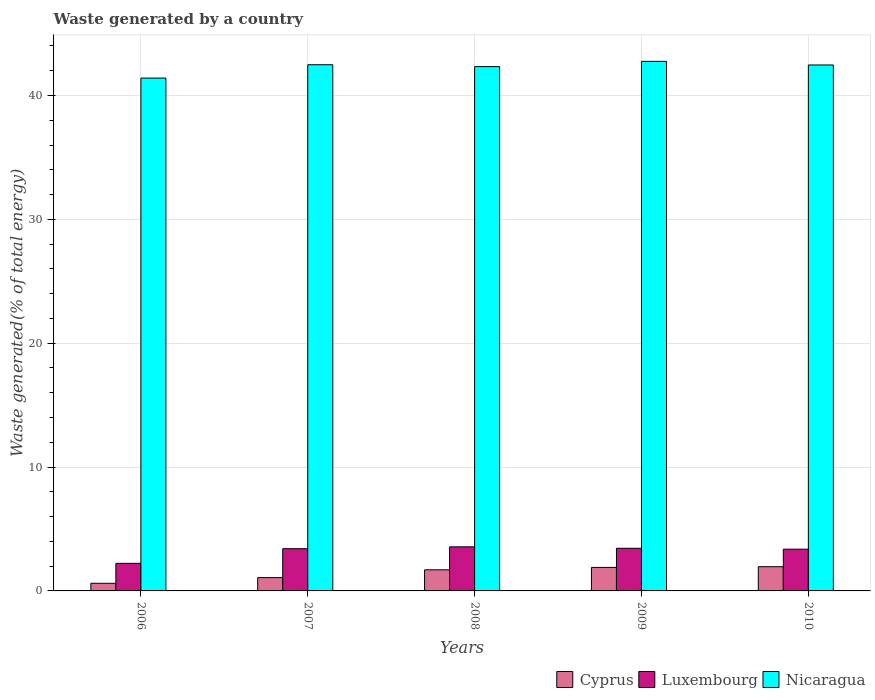How many different coloured bars are there?
Provide a succinct answer. 3. Are the number of bars per tick equal to the number of legend labels?
Provide a succinct answer. Yes. Are the number of bars on each tick of the X-axis equal?
Offer a very short reply. Yes. How many bars are there on the 4th tick from the left?
Keep it short and to the point. 3. How many bars are there on the 5th tick from the right?
Give a very brief answer. 3. What is the total waste generated in Cyprus in 2008?
Offer a very short reply. 1.7. Across all years, what is the maximum total waste generated in Luxembourg?
Make the answer very short. 3.56. Across all years, what is the minimum total waste generated in Luxembourg?
Your answer should be very brief. 2.23. In which year was the total waste generated in Cyprus maximum?
Ensure brevity in your answer.  2010. What is the total total waste generated in Luxembourg in the graph?
Offer a very short reply. 16.01. What is the difference between the total waste generated in Nicaragua in 2009 and that in 2010?
Your response must be concise. 0.29. What is the difference between the total waste generated in Nicaragua in 2007 and the total waste generated in Cyprus in 2010?
Your answer should be compact. 40.53. What is the average total waste generated in Luxembourg per year?
Your response must be concise. 3.2. In the year 2009, what is the difference between the total waste generated in Cyprus and total waste generated in Luxembourg?
Your response must be concise. -1.55. In how many years, is the total waste generated in Cyprus greater than 16 %?
Your answer should be compact. 0. What is the ratio of the total waste generated in Luxembourg in 2009 to that in 2010?
Provide a succinct answer. 1.02. What is the difference between the highest and the second highest total waste generated in Nicaragua?
Provide a short and direct response. 0.27. What is the difference between the highest and the lowest total waste generated in Luxembourg?
Give a very brief answer. 1.33. In how many years, is the total waste generated in Luxembourg greater than the average total waste generated in Luxembourg taken over all years?
Provide a succinct answer. 4. What does the 1st bar from the left in 2008 represents?
Give a very brief answer. Cyprus. What does the 2nd bar from the right in 2008 represents?
Your answer should be compact. Luxembourg. How many bars are there?
Give a very brief answer. 15. Are all the bars in the graph horizontal?
Make the answer very short. No. How many years are there in the graph?
Offer a very short reply. 5. Are the values on the major ticks of Y-axis written in scientific E-notation?
Ensure brevity in your answer.  No. How are the legend labels stacked?
Your response must be concise. Horizontal. What is the title of the graph?
Your answer should be compact. Waste generated by a country. Does "Belarus" appear as one of the legend labels in the graph?
Offer a very short reply. No. What is the label or title of the Y-axis?
Offer a terse response. Waste generated(% of total energy). What is the Waste generated(% of total energy) in Cyprus in 2006?
Provide a succinct answer. 0.62. What is the Waste generated(% of total energy) in Luxembourg in 2006?
Offer a very short reply. 2.23. What is the Waste generated(% of total energy) of Nicaragua in 2006?
Your response must be concise. 41.41. What is the Waste generated(% of total energy) of Cyprus in 2007?
Your answer should be compact. 1.07. What is the Waste generated(% of total energy) of Luxembourg in 2007?
Give a very brief answer. 3.41. What is the Waste generated(% of total energy) in Nicaragua in 2007?
Keep it short and to the point. 42.48. What is the Waste generated(% of total energy) in Cyprus in 2008?
Offer a terse response. 1.7. What is the Waste generated(% of total energy) of Luxembourg in 2008?
Give a very brief answer. 3.56. What is the Waste generated(% of total energy) in Nicaragua in 2008?
Make the answer very short. 42.33. What is the Waste generated(% of total energy) in Cyprus in 2009?
Make the answer very short. 1.9. What is the Waste generated(% of total energy) in Luxembourg in 2009?
Keep it short and to the point. 3.44. What is the Waste generated(% of total energy) of Nicaragua in 2009?
Your answer should be very brief. 42.76. What is the Waste generated(% of total energy) in Cyprus in 2010?
Keep it short and to the point. 1.96. What is the Waste generated(% of total energy) in Luxembourg in 2010?
Your response must be concise. 3.37. What is the Waste generated(% of total energy) of Nicaragua in 2010?
Give a very brief answer. 42.47. Across all years, what is the maximum Waste generated(% of total energy) in Cyprus?
Ensure brevity in your answer.  1.96. Across all years, what is the maximum Waste generated(% of total energy) in Luxembourg?
Your answer should be very brief. 3.56. Across all years, what is the maximum Waste generated(% of total energy) of Nicaragua?
Offer a very short reply. 42.76. Across all years, what is the minimum Waste generated(% of total energy) in Cyprus?
Make the answer very short. 0.62. Across all years, what is the minimum Waste generated(% of total energy) in Luxembourg?
Make the answer very short. 2.23. Across all years, what is the minimum Waste generated(% of total energy) of Nicaragua?
Make the answer very short. 41.41. What is the total Waste generated(% of total energy) of Cyprus in the graph?
Give a very brief answer. 7.25. What is the total Waste generated(% of total energy) in Luxembourg in the graph?
Ensure brevity in your answer.  16.01. What is the total Waste generated(% of total energy) in Nicaragua in the graph?
Provide a succinct answer. 211.45. What is the difference between the Waste generated(% of total energy) of Cyprus in 2006 and that in 2007?
Offer a terse response. -0.46. What is the difference between the Waste generated(% of total energy) of Luxembourg in 2006 and that in 2007?
Offer a very short reply. -1.18. What is the difference between the Waste generated(% of total energy) in Nicaragua in 2006 and that in 2007?
Your answer should be compact. -1.08. What is the difference between the Waste generated(% of total energy) of Cyprus in 2006 and that in 2008?
Keep it short and to the point. -1.09. What is the difference between the Waste generated(% of total energy) of Luxembourg in 2006 and that in 2008?
Ensure brevity in your answer.  -1.33. What is the difference between the Waste generated(% of total energy) of Nicaragua in 2006 and that in 2008?
Provide a short and direct response. -0.92. What is the difference between the Waste generated(% of total energy) in Cyprus in 2006 and that in 2009?
Give a very brief answer. -1.28. What is the difference between the Waste generated(% of total energy) in Luxembourg in 2006 and that in 2009?
Your response must be concise. -1.22. What is the difference between the Waste generated(% of total energy) in Nicaragua in 2006 and that in 2009?
Keep it short and to the point. -1.35. What is the difference between the Waste generated(% of total energy) of Cyprus in 2006 and that in 2010?
Your answer should be compact. -1.34. What is the difference between the Waste generated(% of total energy) of Luxembourg in 2006 and that in 2010?
Make the answer very short. -1.14. What is the difference between the Waste generated(% of total energy) of Nicaragua in 2006 and that in 2010?
Offer a very short reply. -1.06. What is the difference between the Waste generated(% of total energy) in Cyprus in 2007 and that in 2008?
Your response must be concise. -0.63. What is the difference between the Waste generated(% of total energy) of Luxembourg in 2007 and that in 2008?
Your response must be concise. -0.15. What is the difference between the Waste generated(% of total energy) in Nicaragua in 2007 and that in 2008?
Keep it short and to the point. 0.15. What is the difference between the Waste generated(% of total energy) of Cyprus in 2007 and that in 2009?
Your answer should be compact. -0.82. What is the difference between the Waste generated(% of total energy) of Luxembourg in 2007 and that in 2009?
Keep it short and to the point. -0.04. What is the difference between the Waste generated(% of total energy) of Nicaragua in 2007 and that in 2009?
Offer a terse response. -0.27. What is the difference between the Waste generated(% of total energy) of Cyprus in 2007 and that in 2010?
Offer a terse response. -0.88. What is the difference between the Waste generated(% of total energy) of Luxembourg in 2007 and that in 2010?
Offer a very short reply. 0.04. What is the difference between the Waste generated(% of total energy) in Nicaragua in 2007 and that in 2010?
Provide a succinct answer. 0.02. What is the difference between the Waste generated(% of total energy) of Cyprus in 2008 and that in 2009?
Keep it short and to the point. -0.19. What is the difference between the Waste generated(% of total energy) in Luxembourg in 2008 and that in 2009?
Offer a terse response. 0.12. What is the difference between the Waste generated(% of total energy) in Nicaragua in 2008 and that in 2009?
Offer a very short reply. -0.43. What is the difference between the Waste generated(% of total energy) of Cyprus in 2008 and that in 2010?
Give a very brief answer. -0.25. What is the difference between the Waste generated(% of total energy) of Luxembourg in 2008 and that in 2010?
Provide a short and direct response. 0.19. What is the difference between the Waste generated(% of total energy) in Nicaragua in 2008 and that in 2010?
Offer a very short reply. -0.13. What is the difference between the Waste generated(% of total energy) in Cyprus in 2009 and that in 2010?
Keep it short and to the point. -0.06. What is the difference between the Waste generated(% of total energy) in Luxembourg in 2009 and that in 2010?
Keep it short and to the point. 0.07. What is the difference between the Waste generated(% of total energy) of Nicaragua in 2009 and that in 2010?
Your response must be concise. 0.29. What is the difference between the Waste generated(% of total energy) of Cyprus in 2006 and the Waste generated(% of total energy) of Luxembourg in 2007?
Offer a very short reply. -2.79. What is the difference between the Waste generated(% of total energy) in Cyprus in 2006 and the Waste generated(% of total energy) in Nicaragua in 2007?
Ensure brevity in your answer.  -41.87. What is the difference between the Waste generated(% of total energy) of Luxembourg in 2006 and the Waste generated(% of total energy) of Nicaragua in 2007?
Offer a very short reply. -40.26. What is the difference between the Waste generated(% of total energy) of Cyprus in 2006 and the Waste generated(% of total energy) of Luxembourg in 2008?
Your answer should be compact. -2.94. What is the difference between the Waste generated(% of total energy) in Cyprus in 2006 and the Waste generated(% of total energy) in Nicaragua in 2008?
Provide a succinct answer. -41.72. What is the difference between the Waste generated(% of total energy) of Luxembourg in 2006 and the Waste generated(% of total energy) of Nicaragua in 2008?
Provide a short and direct response. -40.1. What is the difference between the Waste generated(% of total energy) of Cyprus in 2006 and the Waste generated(% of total energy) of Luxembourg in 2009?
Keep it short and to the point. -2.83. What is the difference between the Waste generated(% of total energy) of Cyprus in 2006 and the Waste generated(% of total energy) of Nicaragua in 2009?
Offer a very short reply. -42.14. What is the difference between the Waste generated(% of total energy) of Luxembourg in 2006 and the Waste generated(% of total energy) of Nicaragua in 2009?
Make the answer very short. -40.53. What is the difference between the Waste generated(% of total energy) in Cyprus in 2006 and the Waste generated(% of total energy) in Luxembourg in 2010?
Your response must be concise. -2.75. What is the difference between the Waste generated(% of total energy) in Cyprus in 2006 and the Waste generated(% of total energy) in Nicaragua in 2010?
Ensure brevity in your answer.  -41.85. What is the difference between the Waste generated(% of total energy) in Luxembourg in 2006 and the Waste generated(% of total energy) in Nicaragua in 2010?
Ensure brevity in your answer.  -40.24. What is the difference between the Waste generated(% of total energy) of Cyprus in 2007 and the Waste generated(% of total energy) of Luxembourg in 2008?
Give a very brief answer. -2.49. What is the difference between the Waste generated(% of total energy) of Cyprus in 2007 and the Waste generated(% of total energy) of Nicaragua in 2008?
Ensure brevity in your answer.  -41.26. What is the difference between the Waste generated(% of total energy) of Luxembourg in 2007 and the Waste generated(% of total energy) of Nicaragua in 2008?
Ensure brevity in your answer.  -38.92. What is the difference between the Waste generated(% of total energy) in Cyprus in 2007 and the Waste generated(% of total energy) in Luxembourg in 2009?
Make the answer very short. -2.37. What is the difference between the Waste generated(% of total energy) of Cyprus in 2007 and the Waste generated(% of total energy) of Nicaragua in 2009?
Offer a terse response. -41.68. What is the difference between the Waste generated(% of total energy) of Luxembourg in 2007 and the Waste generated(% of total energy) of Nicaragua in 2009?
Provide a succinct answer. -39.35. What is the difference between the Waste generated(% of total energy) of Cyprus in 2007 and the Waste generated(% of total energy) of Luxembourg in 2010?
Ensure brevity in your answer.  -2.3. What is the difference between the Waste generated(% of total energy) in Cyprus in 2007 and the Waste generated(% of total energy) in Nicaragua in 2010?
Give a very brief answer. -41.39. What is the difference between the Waste generated(% of total energy) of Luxembourg in 2007 and the Waste generated(% of total energy) of Nicaragua in 2010?
Provide a succinct answer. -39.06. What is the difference between the Waste generated(% of total energy) in Cyprus in 2008 and the Waste generated(% of total energy) in Luxembourg in 2009?
Ensure brevity in your answer.  -1.74. What is the difference between the Waste generated(% of total energy) in Cyprus in 2008 and the Waste generated(% of total energy) in Nicaragua in 2009?
Give a very brief answer. -41.05. What is the difference between the Waste generated(% of total energy) of Luxembourg in 2008 and the Waste generated(% of total energy) of Nicaragua in 2009?
Your answer should be very brief. -39.2. What is the difference between the Waste generated(% of total energy) of Cyprus in 2008 and the Waste generated(% of total energy) of Luxembourg in 2010?
Offer a terse response. -1.67. What is the difference between the Waste generated(% of total energy) of Cyprus in 2008 and the Waste generated(% of total energy) of Nicaragua in 2010?
Keep it short and to the point. -40.76. What is the difference between the Waste generated(% of total energy) of Luxembourg in 2008 and the Waste generated(% of total energy) of Nicaragua in 2010?
Provide a succinct answer. -38.91. What is the difference between the Waste generated(% of total energy) in Cyprus in 2009 and the Waste generated(% of total energy) in Luxembourg in 2010?
Keep it short and to the point. -1.47. What is the difference between the Waste generated(% of total energy) in Cyprus in 2009 and the Waste generated(% of total energy) in Nicaragua in 2010?
Ensure brevity in your answer.  -40.57. What is the difference between the Waste generated(% of total energy) of Luxembourg in 2009 and the Waste generated(% of total energy) of Nicaragua in 2010?
Your response must be concise. -39.02. What is the average Waste generated(% of total energy) in Cyprus per year?
Give a very brief answer. 1.45. What is the average Waste generated(% of total energy) of Luxembourg per year?
Your response must be concise. 3.2. What is the average Waste generated(% of total energy) of Nicaragua per year?
Provide a succinct answer. 42.29. In the year 2006, what is the difference between the Waste generated(% of total energy) of Cyprus and Waste generated(% of total energy) of Luxembourg?
Your answer should be very brief. -1.61. In the year 2006, what is the difference between the Waste generated(% of total energy) in Cyprus and Waste generated(% of total energy) in Nicaragua?
Ensure brevity in your answer.  -40.79. In the year 2006, what is the difference between the Waste generated(% of total energy) in Luxembourg and Waste generated(% of total energy) in Nicaragua?
Offer a terse response. -39.18. In the year 2007, what is the difference between the Waste generated(% of total energy) of Cyprus and Waste generated(% of total energy) of Luxembourg?
Your response must be concise. -2.34. In the year 2007, what is the difference between the Waste generated(% of total energy) of Cyprus and Waste generated(% of total energy) of Nicaragua?
Provide a short and direct response. -41.41. In the year 2007, what is the difference between the Waste generated(% of total energy) of Luxembourg and Waste generated(% of total energy) of Nicaragua?
Provide a succinct answer. -39.08. In the year 2008, what is the difference between the Waste generated(% of total energy) in Cyprus and Waste generated(% of total energy) in Luxembourg?
Keep it short and to the point. -1.85. In the year 2008, what is the difference between the Waste generated(% of total energy) of Cyprus and Waste generated(% of total energy) of Nicaragua?
Provide a short and direct response. -40.63. In the year 2008, what is the difference between the Waste generated(% of total energy) in Luxembourg and Waste generated(% of total energy) in Nicaragua?
Your answer should be very brief. -38.77. In the year 2009, what is the difference between the Waste generated(% of total energy) of Cyprus and Waste generated(% of total energy) of Luxembourg?
Offer a terse response. -1.55. In the year 2009, what is the difference between the Waste generated(% of total energy) of Cyprus and Waste generated(% of total energy) of Nicaragua?
Your answer should be very brief. -40.86. In the year 2009, what is the difference between the Waste generated(% of total energy) in Luxembourg and Waste generated(% of total energy) in Nicaragua?
Provide a short and direct response. -39.31. In the year 2010, what is the difference between the Waste generated(% of total energy) of Cyprus and Waste generated(% of total energy) of Luxembourg?
Offer a terse response. -1.41. In the year 2010, what is the difference between the Waste generated(% of total energy) in Cyprus and Waste generated(% of total energy) in Nicaragua?
Provide a short and direct response. -40.51. In the year 2010, what is the difference between the Waste generated(% of total energy) in Luxembourg and Waste generated(% of total energy) in Nicaragua?
Your response must be concise. -39.1. What is the ratio of the Waste generated(% of total energy) in Cyprus in 2006 to that in 2007?
Provide a short and direct response. 0.57. What is the ratio of the Waste generated(% of total energy) in Luxembourg in 2006 to that in 2007?
Your answer should be very brief. 0.65. What is the ratio of the Waste generated(% of total energy) of Nicaragua in 2006 to that in 2007?
Offer a terse response. 0.97. What is the ratio of the Waste generated(% of total energy) of Cyprus in 2006 to that in 2008?
Provide a succinct answer. 0.36. What is the ratio of the Waste generated(% of total energy) of Luxembourg in 2006 to that in 2008?
Give a very brief answer. 0.63. What is the ratio of the Waste generated(% of total energy) of Nicaragua in 2006 to that in 2008?
Your answer should be compact. 0.98. What is the ratio of the Waste generated(% of total energy) in Cyprus in 2006 to that in 2009?
Provide a succinct answer. 0.32. What is the ratio of the Waste generated(% of total energy) of Luxembourg in 2006 to that in 2009?
Ensure brevity in your answer.  0.65. What is the ratio of the Waste generated(% of total energy) in Nicaragua in 2006 to that in 2009?
Provide a succinct answer. 0.97. What is the ratio of the Waste generated(% of total energy) in Cyprus in 2006 to that in 2010?
Make the answer very short. 0.31. What is the ratio of the Waste generated(% of total energy) of Luxembourg in 2006 to that in 2010?
Keep it short and to the point. 0.66. What is the ratio of the Waste generated(% of total energy) of Nicaragua in 2006 to that in 2010?
Keep it short and to the point. 0.98. What is the ratio of the Waste generated(% of total energy) of Cyprus in 2007 to that in 2008?
Your answer should be compact. 0.63. What is the ratio of the Waste generated(% of total energy) in Luxembourg in 2007 to that in 2008?
Ensure brevity in your answer.  0.96. What is the ratio of the Waste generated(% of total energy) of Nicaragua in 2007 to that in 2008?
Offer a terse response. 1. What is the ratio of the Waste generated(% of total energy) in Cyprus in 2007 to that in 2009?
Ensure brevity in your answer.  0.57. What is the ratio of the Waste generated(% of total energy) of Luxembourg in 2007 to that in 2009?
Provide a short and direct response. 0.99. What is the ratio of the Waste generated(% of total energy) of Cyprus in 2007 to that in 2010?
Keep it short and to the point. 0.55. What is the ratio of the Waste generated(% of total energy) in Luxembourg in 2007 to that in 2010?
Provide a succinct answer. 1.01. What is the ratio of the Waste generated(% of total energy) in Cyprus in 2008 to that in 2009?
Provide a succinct answer. 0.9. What is the ratio of the Waste generated(% of total energy) of Luxembourg in 2008 to that in 2009?
Ensure brevity in your answer.  1.03. What is the ratio of the Waste generated(% of total energy) of Nicaragua in 2008 to that in 2009?
Your response must be concise. 0.99. What is the ratio of the Waste generated(% of total energy) of Cyprus in 2008 to that in 2010?
Give a very brief answer. 0.87. What is the ratio of the Waste generated(% of total energy) in Luxembourg in 2008 to that in 2010?
Your response must be concise. 1.06. What is the ratio of the Waste generated(% of total energy) of Cyprus in 2009 to that in 2010?
Offer a terse response. 0.97. What is the ratio of the Waste generated(% of total energy) of Luxembourg in 2009 to that in 2010?
Provide a succinct answer. 1.02. What is the ratio of the Waste generated(% of total energy) of Nicaragua in 2009 to that in 2010?
Give a very brief answer. 1.01. What is the difference between the highest and the second highest Waste generated(% of total energy) of Cyprus?
Your response must be concise. 0.06. What is the difference between the highest and the second highest Waste generated(% of total energy) of Luxembourg?
Provide a short and direct response. 0.12. What is the difference between the highest and the second highest Waste generated(% of total energy) of Nicaragua?
Give a very brief answer. 0.27. What is the difference between the highest and the lowest Waste generated(% of total energy) of Cyprus?
Offer a very short reply. 1.34. What is the difference between the highest and the lowest Waste generated(% of total energy) of Luxembourg?
Keep it short and to the point. 1.33. What is the difference between the highest and the lowest Waste generated(% of total energy) in Nicaragua?
Give a very brief answer. 1.35. 